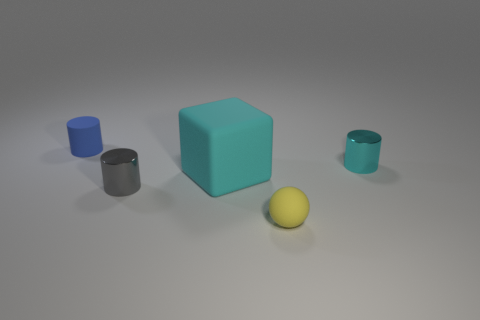Subtract all metallic cylinders. How many cylinders are left? 1 Add 4 red cylinders. How many objects exist? 9 Subtract all cyan cylinders. How many cylinders are left? 2 Subtract 1 balls. How many balls are left? 0 Subtract all cylinders. How many objects are left? 2 Add 5 large cyan rubber objects. How many large cyan rubber objects are left? 6 Add 3 tiny cyan rubber spheres. How many tiny cyan rubber spheres exist? 3 Subtract 0 yellow blocks. How many objects are left? 5 Subtract all gray blocks. Subtract all gray cylinders. How many blocks are left? 1 Subtract all large things. Subtract all big brown cylinders. How many objects are left? 4 